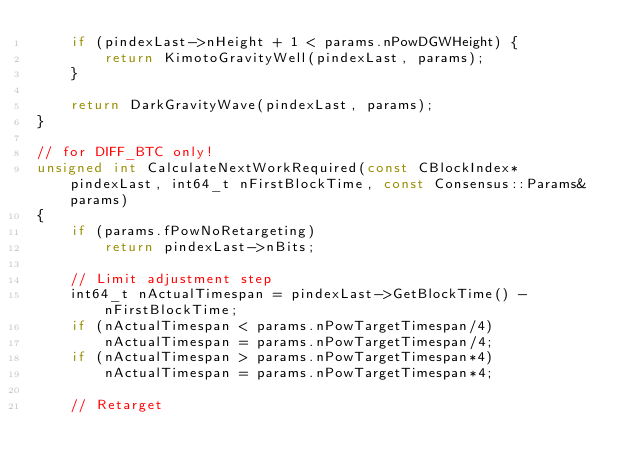Convert code to text. <code><loc_0><loc_0><loc_500><loc_500><_C++_>    if (pindexLast->nHeight + 1 < params.nPowDGWHeight) {
        return KimotoGravityWell(pindexLast, params);
    }

    return DarkGravityWave(pindexLast, params);
}

// for DIFF_BTC only!
unsigned int CalculateNextWorkRequired(const CBlockIndex* pindexLast, int64_t nFirstBlockTime, const Consensus::Params& params)
{
    if (params.fPowNoRetargeting)
        return pindexLast->nBits;

    // Limit adjustment step
    int64_t nActualTimespan = pindexLast->GetBlockTime() - nFirstBlockTime;
    if (nActualTimespan < params.nPowTargetTimespan/4)
        nActualTimespan = params.nPowTargetTimespan/4;
    if (nActualTimespan > params.nPowTargetTimespan*4)
        nActualTimespan = params.nPowTargetTimespan*4;

    // Retarget</code> 